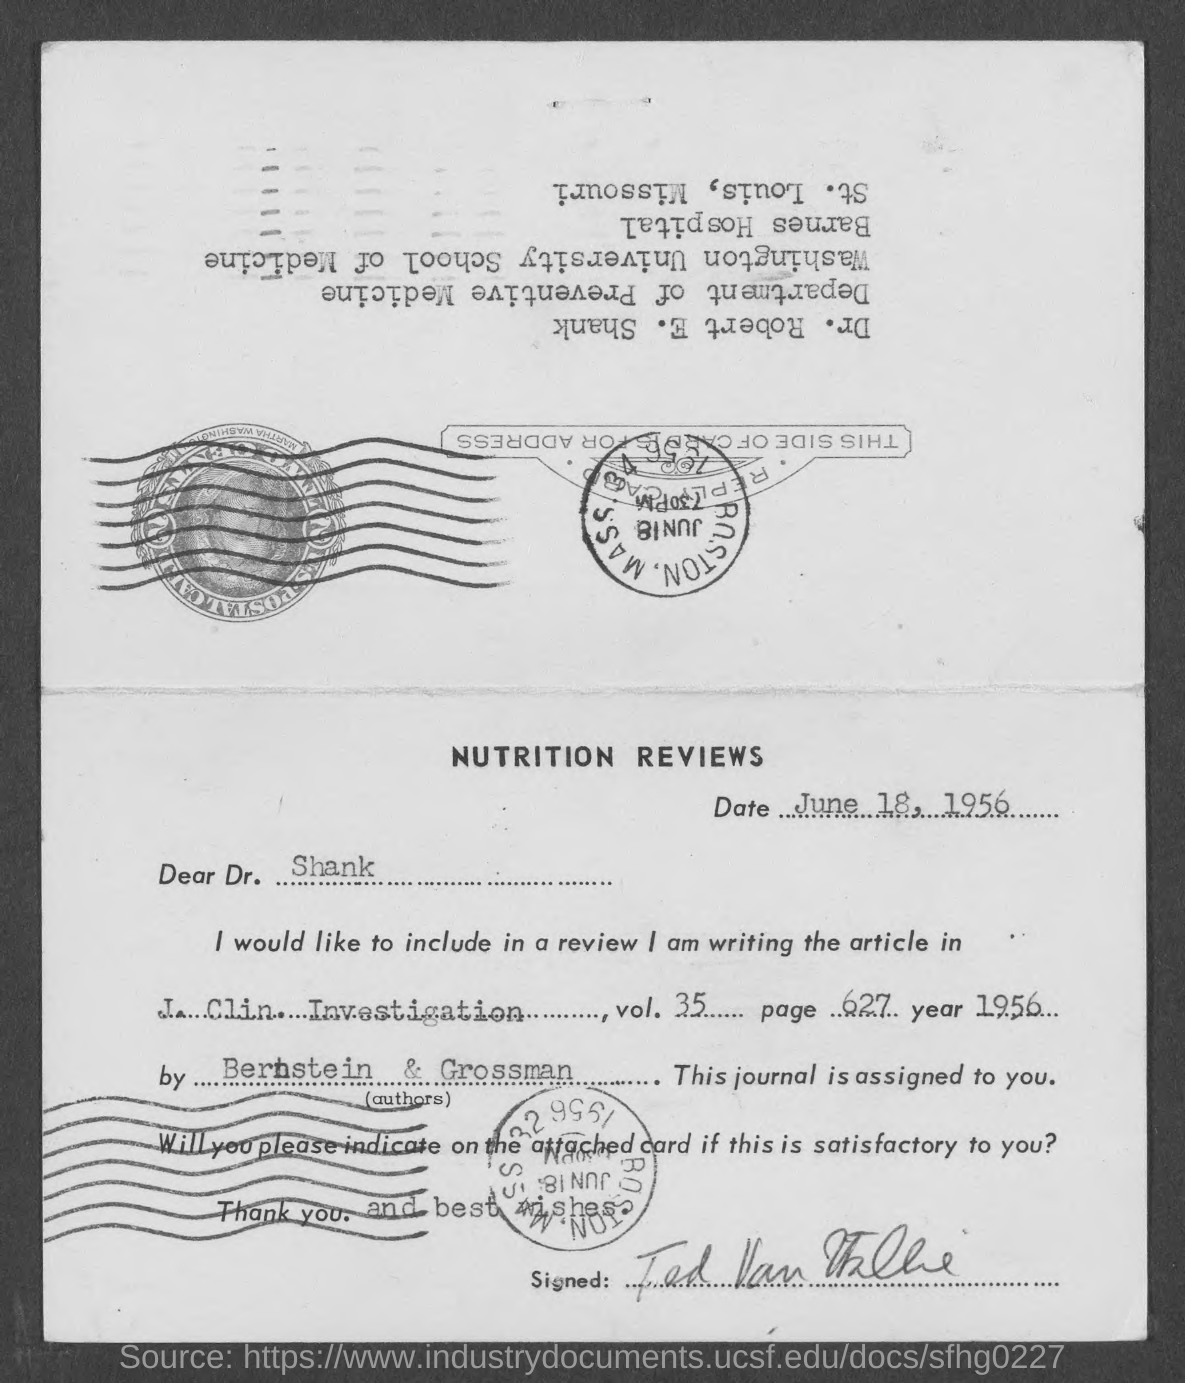What is the date mentioned in this document?
Offer a terse response. June 18, 1956. To whom, the document is addressed?
Provide a short and direct response. Dr. Shank. What is the page no of the article mentioned in this document?
Your answer should be very brief. Page 627. 